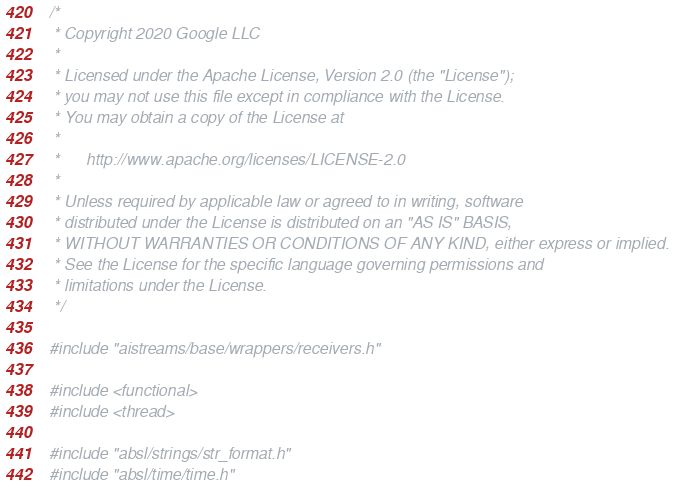Convert code to text. <code><loc_0><loc_0><loc_500><loc_500><_C++_>/*
 * Copyright 2020 Google LLC
 *
 * Licensed under the Apache License, Version 2.0 (the "License");
 * you may not use this file except in compliance with the License.
 * You may obtain a copy of the License at
 *
 *      http://www.apache.org/licenses/LICENSE-2.0
 *
 * Unless required by applicable law or agreed to in writing, software
 * distributed under the License is distributed on an "AS IS" BASIS,
 * WITHOUT WARRANTIES OR CONDITIONS OF ANY KIND, either express or implied.
 * See the License for the specific language governing permissions and
 * limitations under the License.
 */

#include "aistreams/base/wrappers/receivers.h"

#include <functional>
#include <thread>

#include "absl/strings/str_format.h"
#include "absl/time/time.h"</code> 